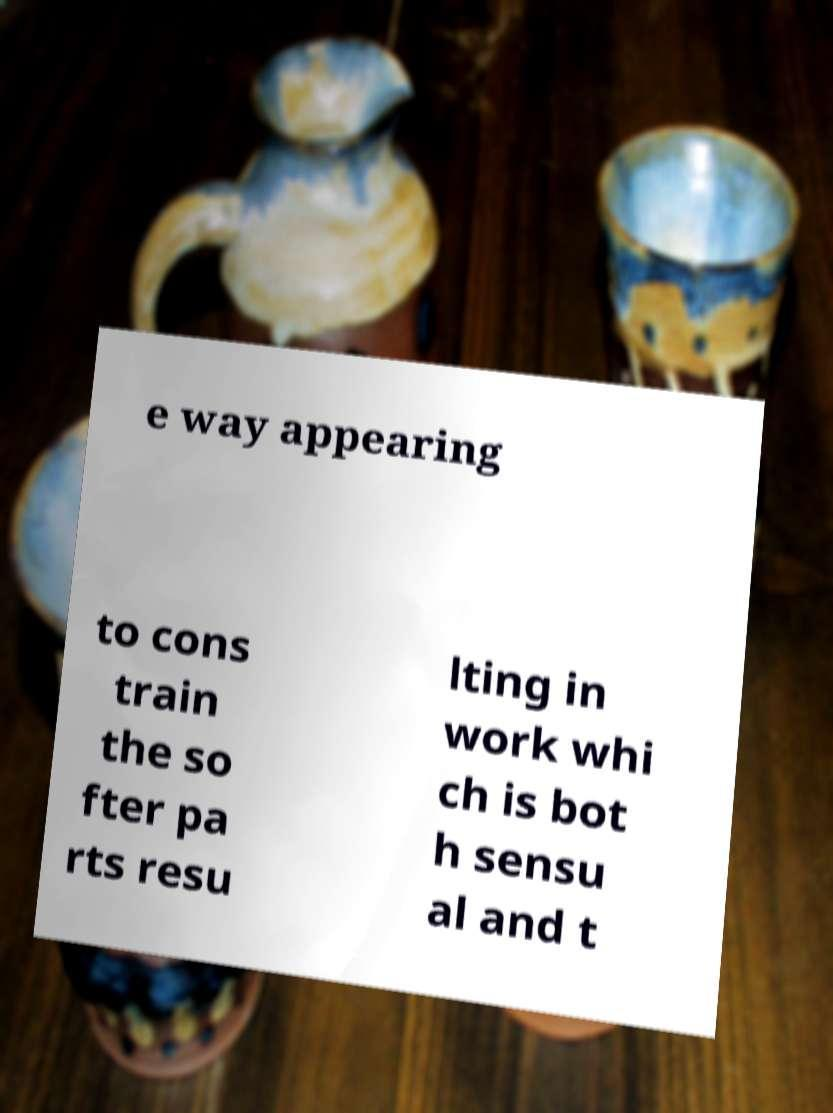Could you assist in decoding the text presented in this image and type it out clearly? e way appearing to cons train the so fter pa rts resu lting in work whi ch is bot h sensu al and t 